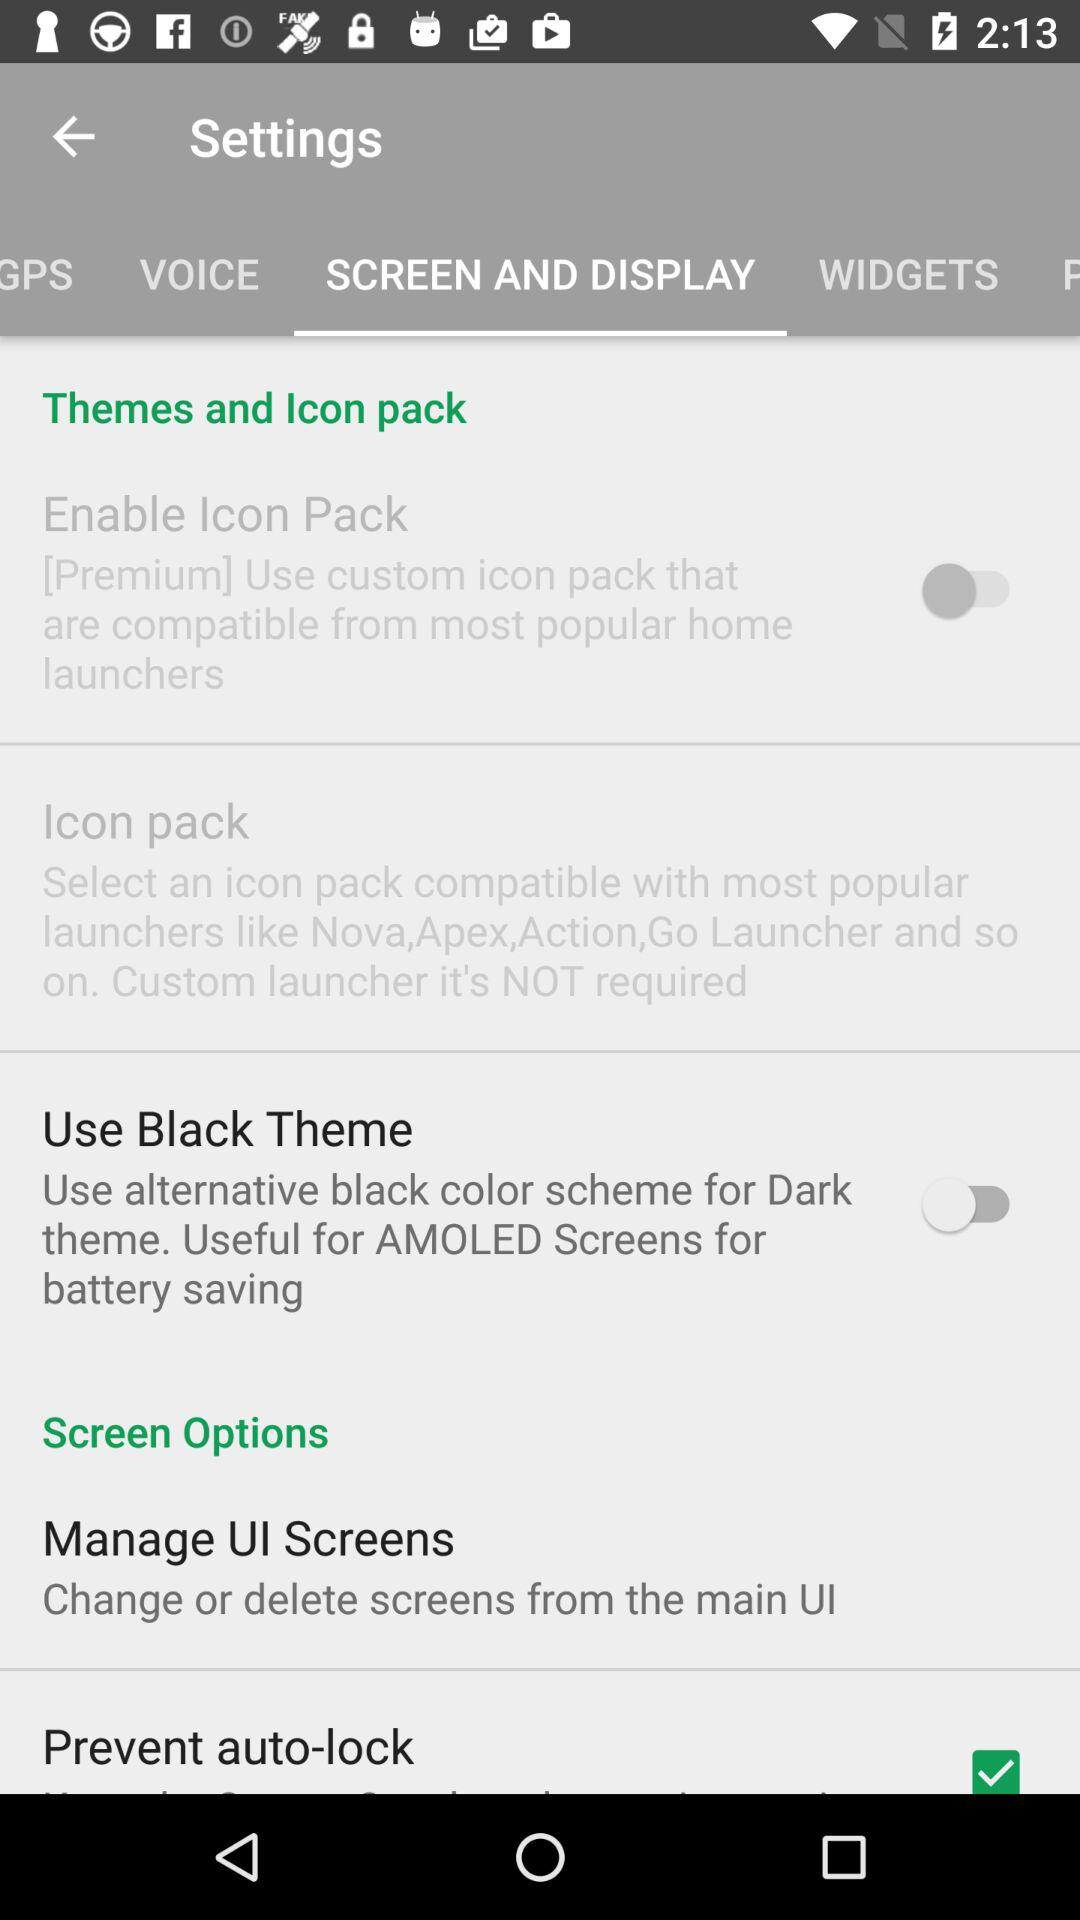How to use black theme?
When the provided information is insufficient, respond with <no answer>. <no answer> 